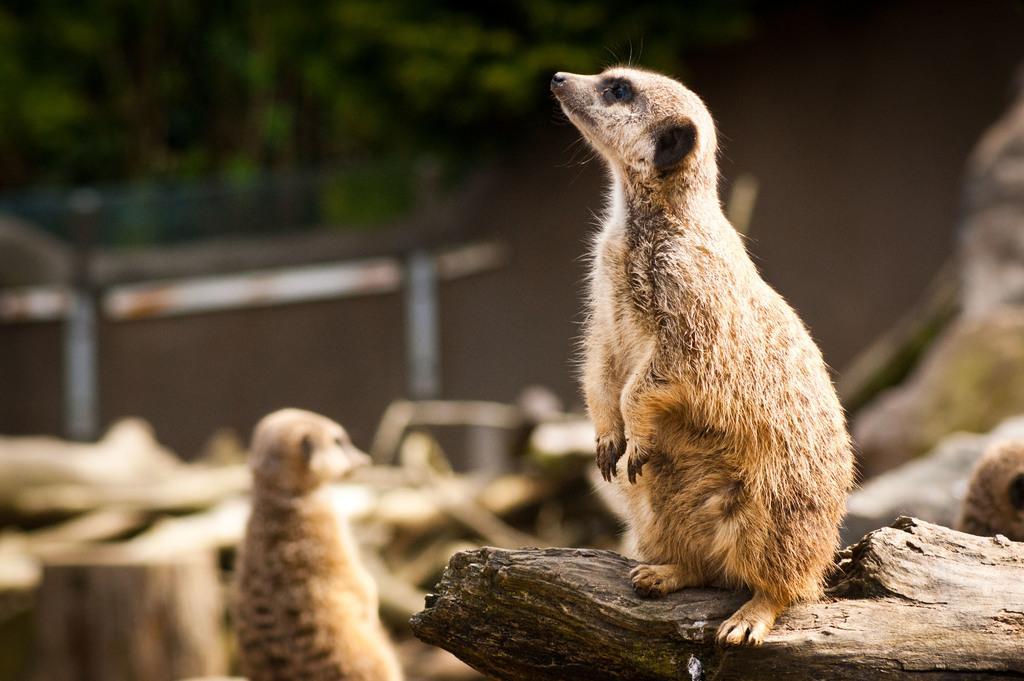Can you describe this image briefly? This picture shows few animals. We see one is seated on the tree bark and they are brown in color. 